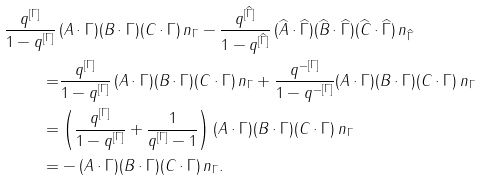Convert formula to latex. <formula><loc_0><loc_0><loc_500><loc_500>\frac { q ^ { [ \Gamma ] } } { 1 - q ^ { [ \Gamma ] } } \, & ( A \cdot \Gamma ) ( B \cdot \Gamma ) ( C \cdot \Gamma ) \, n _ { \Gamma } - \frac { q ^ { [ \widehat { \Gamma } ] } } { 1 - q ^ { [ \widehat { \Gamma } ] } } \, ( \widehat { A } \cdot \widehat { \Gamma } ) ( \widehat { B } \cdot \widehat { \Gamma } ) ( \widehat { C } \cdot \widehat { \Gamma } ) \, n _ { \widehat { \Gamma } } \\ = & \frac { q ^ { [ \Gamma ] } } { 1 - q ^ { [ \Gamma ] } } \, ( A \cdot \Gamma ) ( B \cdot \Gamma ) ( C \cdot \Gamma ) \, n _ { \Gamma } + \frac { q ^ { - [ \Gamma ] } } { 1 - q ^ { - [ \Gamma ] } } ( A \cdot \Gamma ) ( B \cdot \Gamma ) ( C \cdot \Gamma ) \, n _ { \Gamma } \\ = & \left ( \frac { q ^ { [ \Gamma ] } } { 1 - q ^ { [ \Gamma ] } } + \frac { 1 } { q ^ { [ \Gamma ] } - 1 } \right ) ( A \cdot \Gamma ) ( B \cdot \Gamma ) ( C \cdot \Gamma ) \, n _ { \Gamma } \\ = & - ( A \cdot \Gamma ) ( B \cdot \Gamma ) ( C \cdot \Gamma ) \, n _ { \Gamma } .</formula> 